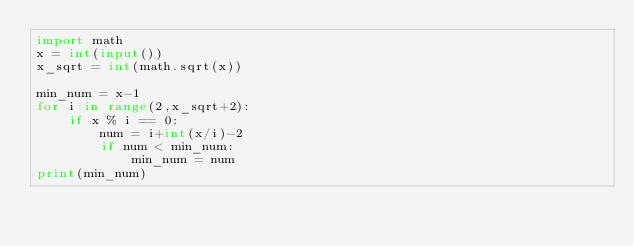<code> <loc_0><loc_0><loc_500><loc_500><_Python_>import math
x = int(input())
x_sqrt = int(math.sqrt(x))

min_num = x-1
for i in range(2,x_sqrt+2):
    if x % i == 0:
        num = i+int(x/i)-2
        if num < min_num:
            min_num = num
print(min_num)</code> 